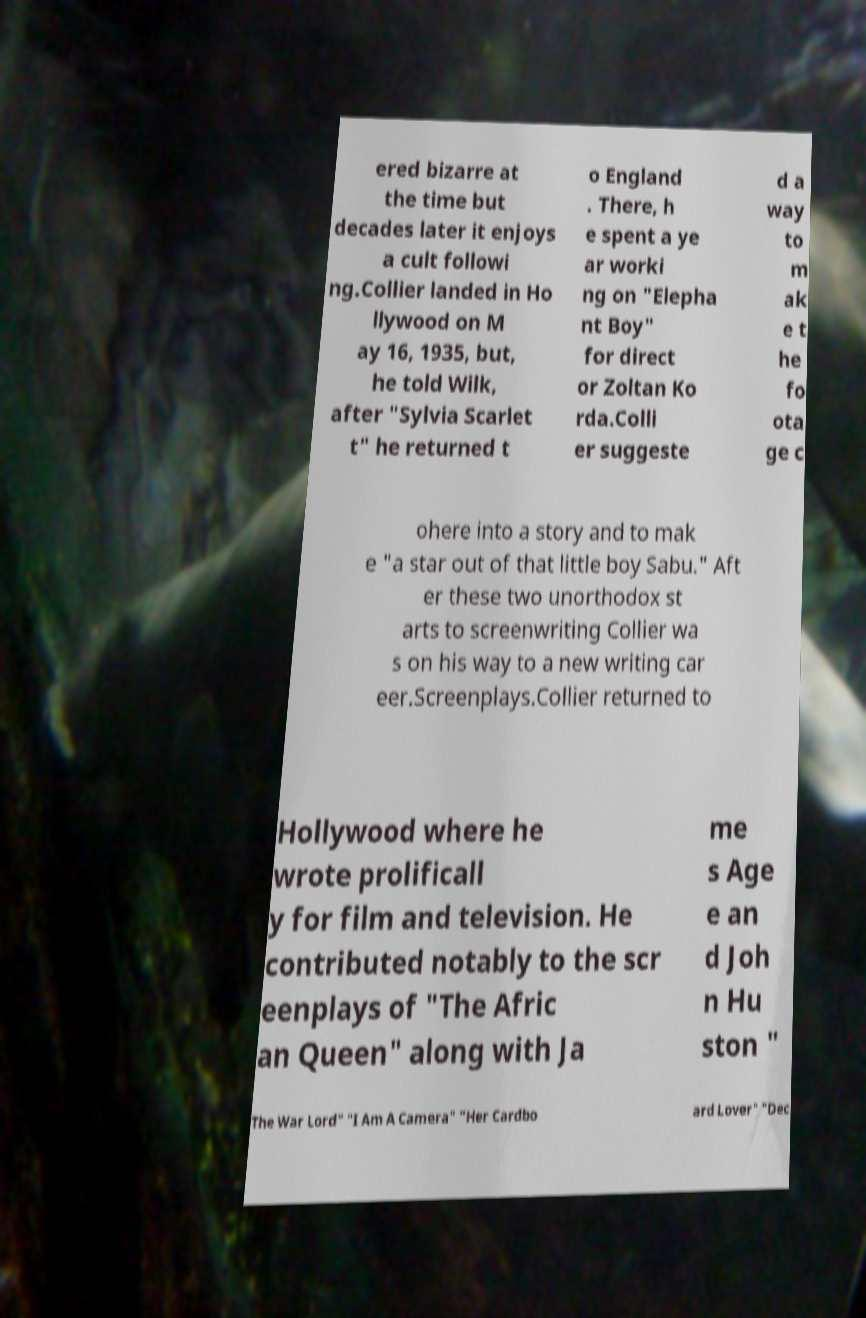Can you accurately transcribe the text from the provided image for me? ered bizarre at the time but decades later it enjoys a cult followi ng.Collier landed in Ho llywood on M ay 16, 1935, but, he told Wilk, after "Sylvia Scarlet t" he returned t o England . There, h e spent a ye ar worki ng on "Elepha nt Boy" for direct or Zoltan Ko rda.Colli er suggeste d a way to m ak e t he fo ota ge c ohere into a story and to mak e "a star out of that little boy Sabu." Aft er these two unorthodox st arts to screenwriting Collier wa s on his way to a new writing car eer.Screenplays.Collier returned to Hollywood where he wrote prolificall y for film and television. He contributed notably to the scr eenplays of "The Afric an Queen" along with Ja me s Age e an d Joh n Hu ston " The War Lord" "I Am A Camera" "Her Cardbo ard Lover" "Dec 